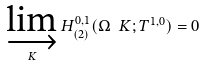<formula> <loc_0><loc_0><loc_500><loc_500>\varinjlim _ { K } H _ { ( 2 ) } ^ { 0 , 1 } ( \Omega \ K ; T ^ { 1 , 0 } ) = 0</formula> 